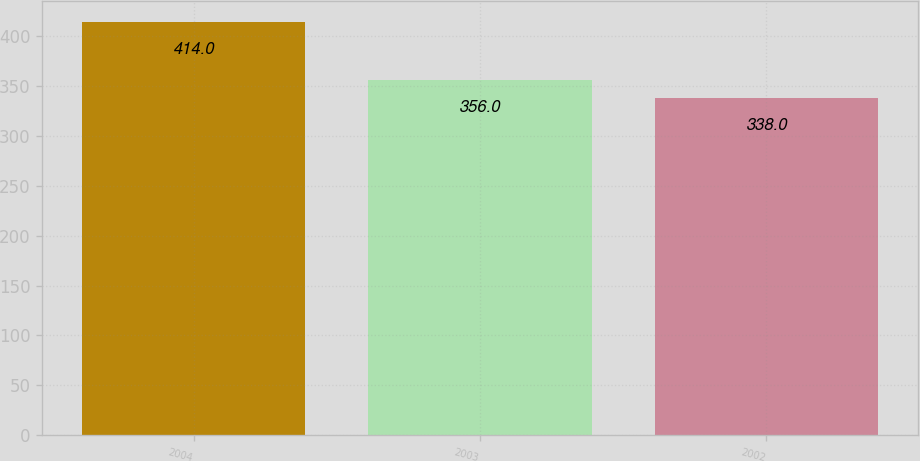Convert chart. <chart><loc_0><loc_0><loc_500><loc_500><bar_chart><fcel>2004<fcel>2003<fcel>2002<nl><fcel>414<fcel>356<fcel>338<nl></chart> 